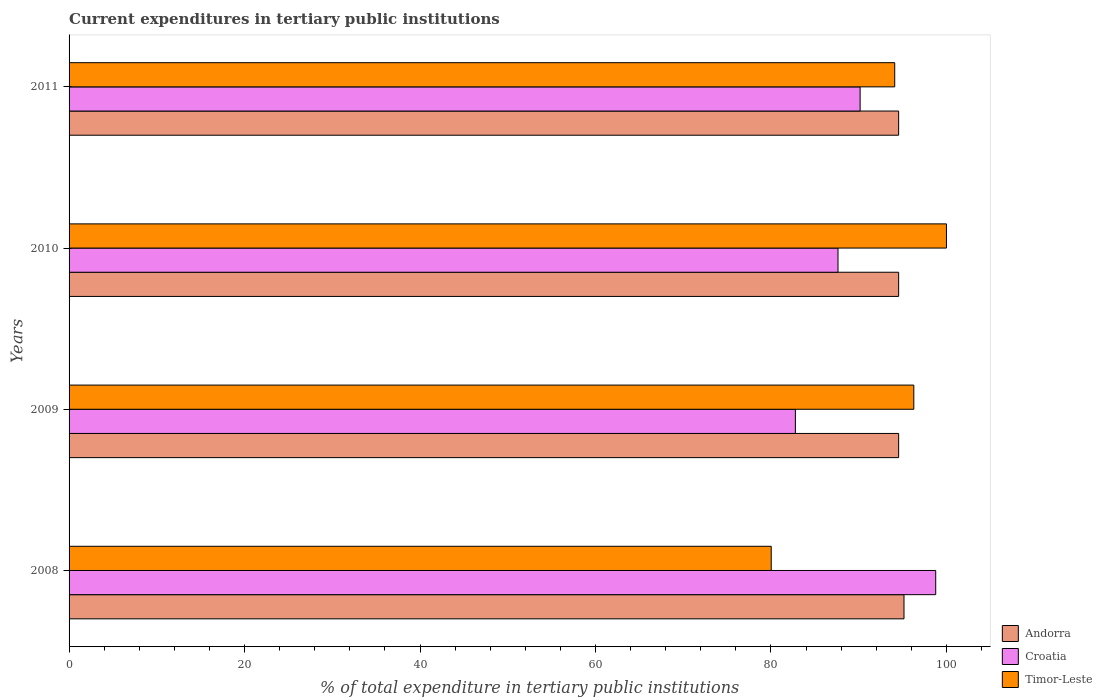How many different coloured bars are there?
Ensure brevity in your answer.  3. Are the number of bars per tick equal to the number of legend labels?
Keep it short and to the point. Yes. How many bars are there on the 4th tick from the bottom?
Offer a very short reply. 3. What is the current expenditures in tertiary public institutions in Timor-Leste in 2011?
Your answer should be very brief. 94.1. Across all years, what is the maximum current expenditures in tertiary public institutions in Croatia?
Offer a very short reply. 98.78. Across all years, what is the minimum current expenditures in tertiary public institutions in Timor-Leste?
Your answer should be very brief. 80.03. In which year was the current expenditures in tertiary public institutions in Andorra minimum?
Ensure brevity in your answer.  2009. What is the total current expenditures in tertiary public institutions in Timor-Leste in the graph?
Offer a very short reply. 370.41. What is the difference between the current expenditures in tertiary public institutions in Timor-Leste in 2008 and that in 2011?
Give a very brief answer. -14.08. What is the difference between the current expenditures in tertiary public institutions in Croatia in 2011 and the current expenditures in tertiary public institutions in Andorra in 2008?
Give a very brief answer. -5. What is the average current expenditures in tertiary public institutions in Andorra per year?
Give a very brief answer. 94.7. In the year 2010, what is the difference between the current expenditures in tertiary public institutions in Timor-Leste and current expenditures in tertiary public institutions in Croatia?
Offer a terse response. 12.36. In how many years, is the current expenditures in tertiary public institutions in Timor-Leste greater than 88 %?
Make the answer very short. 3. What is the ratio of the current expenditures in tertiary public institutions in Andorra in 2008 to that in 2009?
Your response must be concise. 1.01. Is the current expenditures in tertiary public institutions in Croatia in 2008 less than that in 2010?
Your response must be concise. No. Is the difference between the current expenditures in tertiary public institutions in Timor-Leste in 2008 and 2009 greater than the difference between the current expenditures in tertiary public institutions in Croatia in 2008 and 2009?
Provide a succinct answer. No. What is the difference between the highest and the second highest current expenditures in tertiary public institutions in Timor-Leste?
Ensure brevity in your answer.  3.72. What is the difference between the highest and the lowest current expenditures in tertiary public institutions in Croatia?
Keep it short and to the point. 15.99. In how many years, is the current expenditures in tertiary public institutions in Andorra greater than the average current expenditures in tertiary public institutions in Andorra taken over all years?
Your response must be concise. 1. Is the sum of the current expenditures in tertiary public institutions in Andorra in 2009 and 2010 greater than the maximum current expenditures in tertiary public institutions in Timor-Leste across all years?
Keep it short and to the point. Yes. What does the 3rd bar from the top in 2008 represents?
Your response must be concise. Andorra. What does the 3rd bar from the bottom in 2011 represents?
Your answer should be very brief. Timor-Leste. How many years are there in the graph?
Keep it short and to the point. 4. Does the graph contain any zero values?
Your answer should be very brief. No. Does the graph contain grids?
Provide a short and direct response. No. How many legend labels are there?
Your answer should be very brief. 3. What is the title of the graph?
Offer a very short reply. Current expenditures in tertiary public institutions. What is the label or title of the X-axis?
Ensure brevity in your answer.  % of total expenditure in tertiary public institutions. What is the label or title of the Y-axis?
Keep it short and to the point. Years. What is the % of total expenditure in tertiary public institutions of Andorra in 2008?
Provide a short and direct response. 95.16. What is the % of total expenditure in tertiary public institutions of Croatia in 2008?
Provide a short and direct response. 98.78. What is the % of total expenditure in tertiary public institutions in Timor-Leste in 2008?
Make the answer very short. 80.03. What is the % of total expenditure in tertiary public institutions in Andorra in 2009?
Your answer should be compact. 94.55. What is the % of total expenditure in tertiary public institutions in Croatia in 2009?
Provide a short and direct response. 82.78. What is the % of total expenditure in tertiary public institutions in Timor-Leste in 2009?
Keep it short and to the point. 96.28. What is the % of total expenditure in tertiary public institutions in Andorra in 2010?
Offer a terse response. 94.55. What is the % of total expenditure in tertiary public institutions of Croatia in 2010?
Ensure brevity in your answer.  87.64. What is the % of total expenditure in tertiary public institutions in Timor-Leste in 2010?
Provide a succinct answer. 100. What is the % of total expenditure in tertiary public institutions of Andorra in 2011?
Provide a short and direct response. 94.55. What is the % of total expenditure in tertiary public institutions of Croatia in 2011?
Your answer should be very brief. 90.16. What is the % of total expenditure in tertiary public institutions in Timor-Leste in 2011?
Provide a succinct answer. 94.1. Across all years, what is the maximum % of total expenditure in tertiary public institutions of Andorra?
Make the answer very short. 95.16. Across all years, what is the maximum % of total expenditure in tertiary public institutions in Croatia?
Keep it short and to the point. 98.78. Across all years, what is the minimum % of total expenditure in tertiary public institutions in Andorra?
Offer a very short reply. 94.55. Across all years, what is the minimum % of total expenditure in tertiary public institutions of Croatia?
Offer a very short reply. 82.78. Across all years, what is the minimum % of total expenditure in tertiary public institutions in Timor-Leste?
Your response must be concise. 80.03. What is the total % of total expenditure in tertiary public institutions of Andorra in the graph?
Your response must be concise. 378.81. What is the total % of total expenditure in tertiary public institutions of Croatia in the graph?
Your response must be concise. 359.36. What is the total % of total expenditure in tertiary public institutions in Timor-Leste in the graph?
Ensure brevity in your answer.  370.41. What is the difference between the % of total expenditure in tertiary public institutions in Andorra in 2008 and that in 2009?
Provide a short and direct response. 0.61. What is the difference between the % of total expenditure in tertiary public institutions of Croatia in 2008 and that in 2009?
Give a very brief answer. 15.99. What is the difference between the % of total expenditure in tertiary public institutions in Timor-Leste in 2008 and that in 2009?
Your answer should be compact. -16.25. What is the difference between the % of total expenditure in tertiary public institutions in Andorra in 2008 and that in 2010?
Provide a succinct answer. 0.61. What is the difference between the % of total expenditure in tertiary public institutions in Croatia in 2008 and that in 2010?
Keep it short and to the point. 11.13. What is the difference between the % of total expenditure in tertiary public institutions in Timor-Leste in 2008 and that in 2010?
Your answer should be compact. -19.97. What is the difference between the % of total expenditure in tertiary public institutions of Andorra in 2008 and that in 2011?
Provide a short and direct response. 0.61. What is the difference between the % of total expenditure in tertiary public institutions in Croatia in 2008 and that in 2011?
Your response must be concise. 8.62. What is the difference between the % of total expenditure in tertiary public institutions of Timor-Leste in 2008 and that in 2011?
Provide a short and direct response. -14.08. What is the difference between the % of total expenditure in tertiary public institutions in Andorra in 2009 and that in 2010?
Keep it short and to the point. 0. What is the difference between the % of total expenditure in tertiary public institutions in Croatia in 2009 and that in 2010?
Keep it short and to the point. -4.86. What is the difference between the % of total expenditure in tertiary public institutions in Timor-Leste in 2009 and that in 2010?
Offer a very short reply. -3.72. What is the difference between the % of total expenditure in tertiary public institutions in Andorra in 2009 and that in 2011?
Offer a terse response. 0. What is the difference between the % of total expenditure in tertiary public institutions of Croatia in 2009 and that in 2011?
Your response must be concise. -7.38. What is the difference between the % of total expenditure in tertiary public institutions of Timor-Leste in 2009 and that in 2011?
Provide a succinct answer. 2.18. What is the difference between the % of total expenditure in tertiary public institutions of Croatia in 2010 and that in 2011?
Offer a terse response. -2.52. What is the difference between the % of total expenditure in tertiary public institutions in Timor-Leste in 2010 and that in 2011?
Keep it short and to the point. 5.9. What is the difference between the % of total expenditure in tertiary public institutions of Andorra in 2008 and the % of total expenditure in tertiary public institutions of Croatia in 2009?
Offer a terse response. 12.38. What is the difference between the % of total expenditure in tertiary public institutions in Andorra in 2008 and the % of total expenditure in tertiary public institutions in Timor-Leste in 2009?
Your answer should be very brief. -1.12. What is the difference between the % of total expenditure in tertiary public institutions in Croatia in 2008 and the % of total expenditure in tertiary public institutions in Timor-Leste in 2009?
Provide a short and direct response. 2.5. What is the difference between the % of total expenditure in tertiary public institutions of Andorra in 2008 and the % of total expenditure in tertiary public institutions of Croatia in 2010?
Your answer should be very brief. 7.52. What is the difference between the % of total expenditure in tertiary public institutions of Andorra in 2008 and the % of total expenditure in tertiary public institutions of Timor-Leste in 2010?
Provide a succinct answer. -4.84. What is the difference between the % of total expenditure in tertiary public institutions of Croatia in 2008 and the % of total expenditure in tertiary public institutions of Timor-Leste in 2010?
Provide a short and direct response. -1.22. What is the difference between the % of total expenditure in tertiary public institutions in Andorra in 2008 and the % of total expenditure in tertiary public institutions in Croatia in 2011?
Provide a short and direct response. 5. What is the difference between the % of total expenditure in tertiary public institutions in Andorra in 2008 and the % of total expenditure in tertiary public institutions in Timor-Leste in 2011?
Keep it short and to the point. 1.06. What is the difference between the % of total expenditure in tertiary public institutions of Croatia in 2008 and the % of total expenditure in tertiary public institutions of Timor-Leste in 2011?
Give a very brief answer. 4.67. What is the difference between the % of total expenditure in tertiary public institutions of Andorra in 2009 and the % of total expenditure in tertiary public institutions of Croatia in 2010?
Offer a terse response. 6.91. What is the difference between the % of total expenditure in tertiary public institutions in Andorra in 2009 and the % of total expenditure in tertiary public institutions in Timor-Leste in 2010?
Provide a succinct answer. -5.45. What is the difference between the % of total expenditure in tertiary public institutions in Croatia in 2009 and the % of total expenditure in tertiary public institutions in Timor-Leste in 2010?
Provide a succinct answer. -17.22. What is the difference between the % of total expenditure in tertiary public institutions of Andorra in 2009 and the % of total expenditure in tertiary public institutions of Croatia in 2011?
Provide a succinct answer. 4.39. What is the difference between the % of total expenditure in tertiary public institutions of Andorra in 2009 and the % of total expenditure in tertiary public institutions of Timor-Leste in 2011?
Ensure brevity in your answer.  0.45. What is the difference between the % of total expenditure in tertiary public institutions in Croatia in 2009 and the % of total expenditure in tertiary public institutions in Timor-Leste in 2011?
Your response must be concise. -11.32. What is the difference between the % of total expenditure in tertiary public institutions in Andorra in 2010 and the % of total expenditure in tertiary public institutions in Croatia in 2011?
Ensure brevity in your answer.  4.39. What is the difference between the % of total expenditure in tertiary public institutions of Andorra in 2010 and the % of total expenditure in tertiary public institutions of Timor-Leste in 2011?
Offer a terse response. 0.45. What is the difference between the % of total expenditure in tertiary public institutions of Croatia in 2010 and the % of total expenditure in tertiary public institutions of Timor-Leste in 2011?
Your response must be concise. -6.46. What is the average % of total expenditure in tertiary public institutions of Andorra per year?
Keep it short and to the point. 94.7. What is the average % of total expenditure in tertiary public institutions in Croatia per year?
Your response must be concise. 89.84. What is the average % of total expenditure in tertiary public institutions of Timor-Leste per year?
Your answer should be very brief. 92.6. In the year 2008, what is the difference between the % of total expenditure in tertiary public institutions in Andorra and % of total expenditure in tertiary public institutions in Croatia?
Keep it short and to the point. -3.62. In the year 2008, what is the difference between the % of total expenditure in tertiary public institutions of Andorra and % of total expenditure in tertiary public institutions of Timor-Leste?
Provide a short and direct response. 15.13. In the year 2008, what is the difference between the % of total expenditure in tertiary public institutions of Croatia and % of total expenditure in tertiary public institutions of Timor-Leste?
Your response must be concise. 18.75. In the year 2009, what is the difference between the % of total expenditure in tertiary public institutions in Andorra and % of total expenditure in tertiary public institutions in Croatia?
Your answer should be very brief. 11.77. In the year 2009, what is the difference between the % of total expenditure in tertiary public institutions in Andorra and % of total expenditure in tertiary public institutions in Timor-Leste?
Provide a succinct answer. -1.73. In the year 2009, what is the difference between the % of total expenditure in tertiary public institutions of Croatia and % of total expenditure in tertiary public institutions of Timor-Leste?
Offer a terse response. -13.5. In the year 2010, what is the difference between the % of total expenditure in tertiary public institutions of Andorra and % of total expenditure in tertiary public institutions of Croatia?
Give a very brief answer. 6.91. In the year 2010, what is the difference between the % of total expenditure in tertiary public institutions of Andorra and % of total expenditure in tertiary public institutions of Timor-Leste?
Offer a very short reply. -5.45. In the year 2010, what is the difference between the % of total expenditure in tertiary public institutions in Croatia and % of total expenditure in tertiary public institutions in Timor-Leste?
Your answer should be very brief. -12.36. In the year 2011, what is the difference between the % of total expenditure in tertiary public institutions of Andorra and % of total expenditure in tertiary public institutions of Croatia?
Offer a terse response. 4.39. In the year 2011, what is the difference between the % of total expenditure in tertiary public institutions of Andorra and % of total expenditure in tertiary public institutions of Timor-Leste?
Your answer should be compact. 0.45. In the year 2011, what is the difference between the % of total expenditure in tertiary public institutions of Croatia and % of total expenditure in tertiary public institutions of Timor-Leste?
Your answer should be compact. -3.94. What is the ratio of the % of total expenditure in tertiary public institutions in Andorra in 2008 to that in 2009?
Your response must be concise. 1.01. What is the ratio of the % of total expenditure in tertiary public institutions in Croatia in 2008 to that in 2009?
Keep it short and to the point. 1.19. What is the ratio of the % of total expenditure in tertiary public institutions in Timor-Leste in 2008 to that in 2009?
Keep it short and to the point. 0.83. What is the ratio of the % of total expenditure in tertiary public institutions of Croatia in 2008 to that in 2010?
Ensure brevity in your answer.  1.13. What is the ratio of the % of total expenditure in tertiary public institutions in Timor-Leste in 2008 to that in 2010?
Provide a succinct answer. 0.8. What is the ratio of the % of total expenditure in tertiary public institutions of Croatia in 2008 to that in 2011?
Offer a very short reply. 1.1. What is the ratio of the % of total expenditure in tertiary public institutions of Timor-Leste in 2008 to that in 2011?
Your answer should be very brief. 0.85. What is the ratio of the % of total expenditure in tertiary public institutions of Andorra in 2009 to that in 2010?
Offer a terse response. 1. What is the ratio of the % of total expenditure in tertiary public institutions of Croatia in 2009 to that in 2010?
Your answer should be compact. 0.94. What is the ratio of the % of total expenditure in tertiary public institutions of Timor-Leste in 2009 to that in 2010?
Offer a terse response. 0.96. What is the ratio of the % of total expenditure in tertiary public institutions of Andorra in 2009 to that in 2011?
Ensure brevity in your answer.  1. What is the ratio of the % of total expenditure in tertiary public institutions in Croatia in 2009 to that in 2011?
Your response must be concise. 0.92. What is the ratio of the % of total expenditure in tertiary public institutions in Timor-Leste in 2009 to that in 2011?
Provide a short and direct response. 1.02. What is the ratio of the % of total expenditure in tertiary public institutions of Croatia in 2010 to that in 2011?
Your response must be concise. 0.97. What is the ratio of the % of total expenditure in tertiary public institutions of Timor-Leste in 2010 to that in 2011?
Ensure brevity in your answer.  1.06. What is the difference between the highest and the second highest % of total expenditure in tertiary public institutions in Andorra?
Ensure brevity in your answer.  0.61. What is the difference between the highest and the second highest % of total expenditure in tertiary public institutions of Croatia?
Provide a succinct answer. 8.62. What is the difference between the highest and the second highest % of total expenditure in tertiary public institutions of Timor-Leste?
Provide a short and direct response. 3.72. What is the difference between the highest and the lowest % of total expenditure in tertiary public institutions in Andorra?
Keep it short and to the point. 0.61. What is the difference between the highest and the lowest % of total expenditure in tertiary public institutions of Croatia?
Provide a succinct answer. 15.99. What is the difference between the highest and the lowest % of total expenditure in tertiary public institutions of Timor-Leste?
Provide a short and direct response. 19.97. 